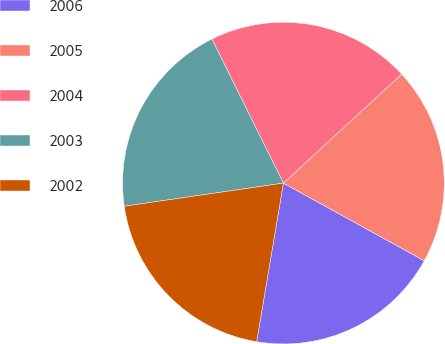Convert chart to OTSL. <chart><loc_0><loc_0><loc_500><loc_500><pie_chart><fcel>2006<fcel>2005<fcel>2004<fcel>2003<fcel>2002<nl><fcel>19.64%<fcel>19.87%<fcel>20.48%<fcel>19.96%<fcel>20.04%<nl></chart> 